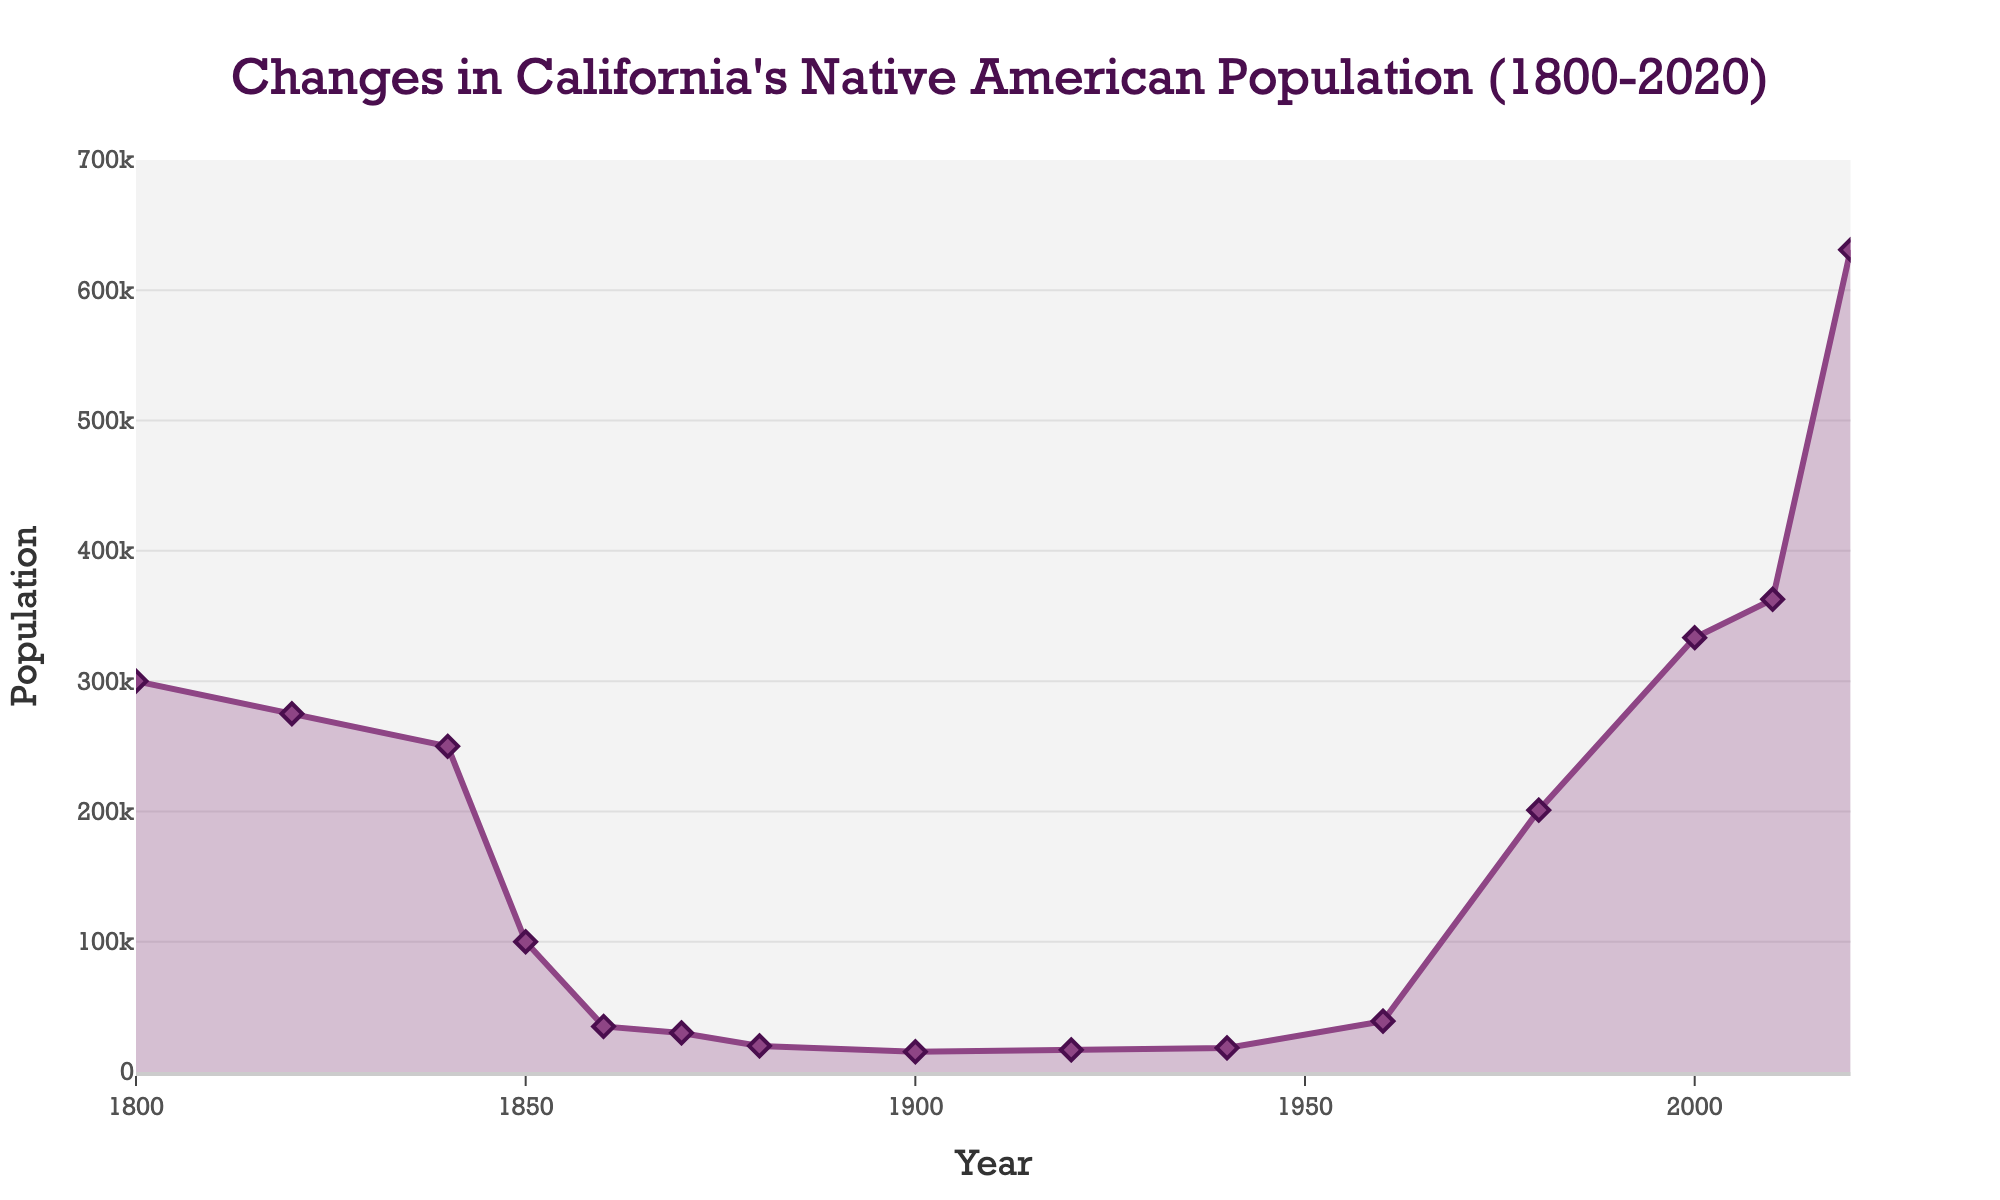What was the Native American population in California in 1850? Referring to the figure, look at the population value for the year 1850 on the x-axis. The value is represented by the height of the line.
Answer: 100,000 What is the difference in population between 2000 and 2020? Locate the population values for the years 2000 and 2020. The values are 333,346 for 2000 and 631,061 for 2020. Subtract the population of 2000 from 2020: 631,061 - 333,346 = 297,715.
Answer: 297,715 During which decade did the Native American population experience the most rapid decline? Observe the sharpest decrease in the population curve. The most rapid decline occurs between 1840 and 1850, where the population dropped from 250,000 to 100,000.
Answer: 1840-1850 Which year had a higher population: 1920 or 1940? Compare the population values for the years 1920 and 1940. In 1920, the population was 17,000 and in 1940, it was 18,500. 1940 had the higher population.
Answer: 1940 By how much did the population change between 1980 and 2010? Find the population values for 1980 and 2010. The values are 201,000 for 1980 and 362,801 for 2010. Subtract the population of 1980 from 2010: 362,801 - 201,000 = 161,801.
Answer: 161,801 What color is used to fill the area under the population curve? Refer to the visual attribute of the area under the curve. The area is filled with a light purple color.
Answer: light purple What was the native population trend from 1900 to 1920? Look at the population values from 1900 (15,500) to 1920 (17,000). The population slightly increased over this period.
Answer: Increase Which year had the highest Native American population? Identify the peak point on the graph. The highest point corresponds to the year 2020, with a population of 631,061.
Answer: 2020 What is the visual attribute of the markers used to depict individual years on the line? Observe the markers along the line. They are diamonds filled with a purple color and outlined in a darker purple.
Answer: diamond markers 